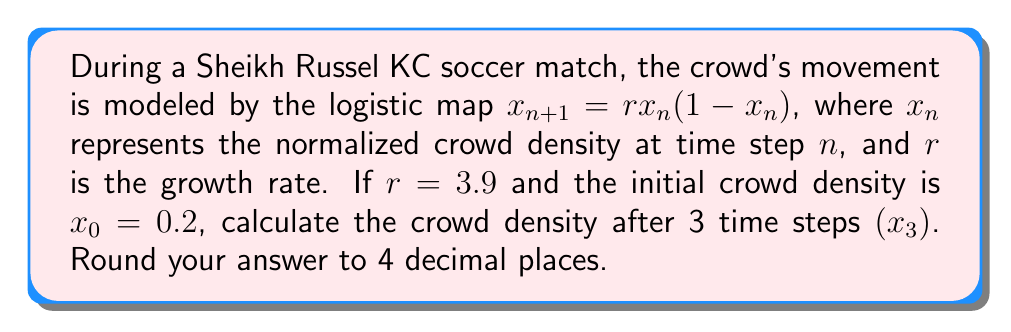What is the answer to this math problem? To solve this problem, we need to iterate the logistic map equation three times:

Step 1: Calculate $x_1$
$$x_1 = r \cdot x_0(1-x_0)$$
$$x_1 = 3.9 \cdot 0.2(1-0.2)$$
$$x_1 = 3.9 \cdot 0.2 \cdot 0.8 = 0.624$$

Step 2: Calculate $x_2$
$$x_2 = r \cdot x_1(1-x_1)$$
$$x_2 = 3.9 \cdot 0.624(1-0.624)$$
$$x_2 = 3.9 \cdot 0.624 \cdot 0.376 = 0.9165696$$

Step 3: Calculate $x_3$
$$x_3 = r \cdot x_2(1-x_2)$$
$$x_3 = 3.9 \cdot 0.9165696(1-0.9165696)$$
$$x_3 = 3.9 \cdot 0.9165696 \cdot 0.0834304 = 0.2986$$

Step 4: Round to 4 decimal places
$x_3 \approx 0.2986$
Answer: 0.2986 